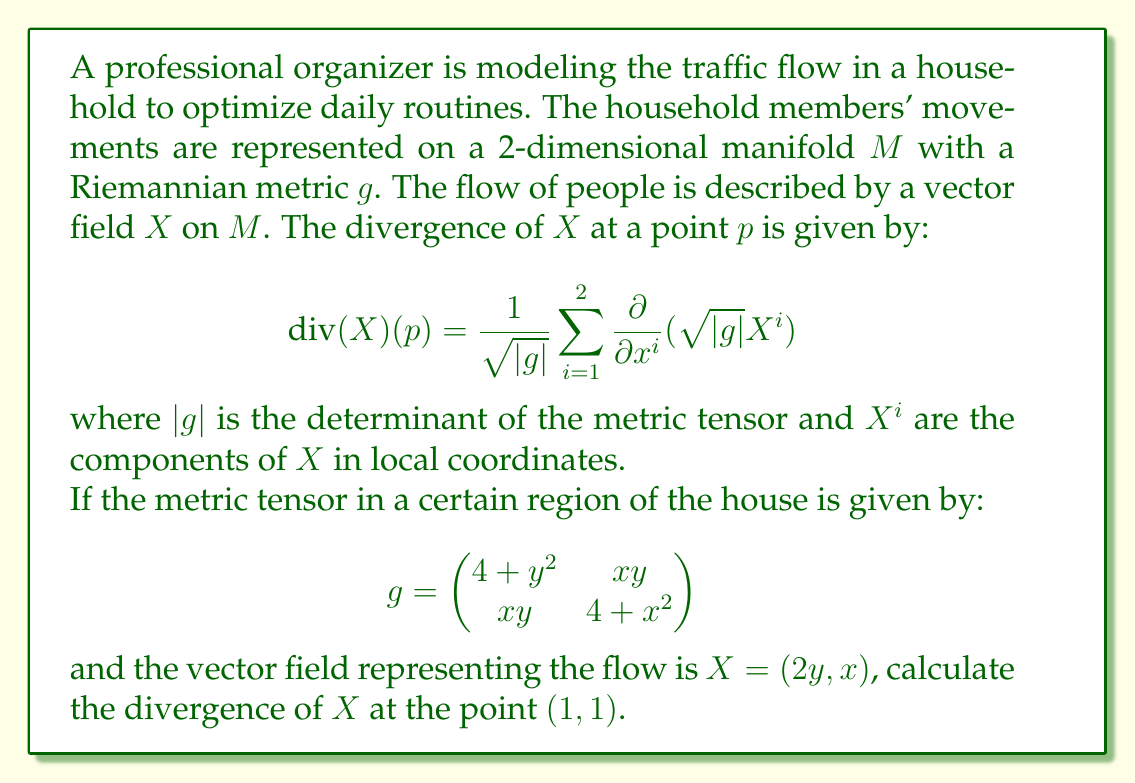Help me with this question. To solve this problem, we need to follow these steps:

1) First, we need to calculate $\sqrt{|g|}$:
   $|g| = (4+y^2)(4+x^2) - (xy)^2$
   At point (1,1): $|g| = (4+1)(4+1) - 1 = 24$
   So, $\sqrt{|g|} = 2\sqrt{6}$ at (1,1)

2) Now, we need to calculate $\frac{\partial}{\partial x^i}(\sqrt{|g|}X^i)$ for i = 1 and 2:

   For i = 1:
   $\frac{\partial}{\partial x}(\sqrt{|g|}X^1) = \frac{\partial}{\partial x}(\sqrt{|g|} \cdot 2y)$
   $= 2y \frac{\partial}{\partial x}(\sqrt{(4+y^2)(4+x^2) - (xy)^2})$
   
   For i = 2:
   $\frac{\partial}{\partial y}(\sqrt{|g|}X^2) = \frac{\partial}{\partial y}(\sqrt{|g|} \cdot x)$
   $= x \frac{\partial}{\partial y}(\sqrt{(4+y^2)(4+x^2) - (xy)^2}) + \sqrt{|g|}$

3) Evaluating these at (1,1):
   
   For i = 1:
   $\frac{\partial}{\partial x}(\sqrt{|g|}X^1)|_{(1,1)} = 2 \cdot \frac{1}{2\sqrt{6}} \cdot (5 \cdot 1 - 1) = \frac{4}{\sqrt{6}}$
   
   For i = 2:
   $\frac{\partial}{\partial y}(\sqrt{|g|}X^2)|_{(1,1)} = 1 \cdot \frac{1}{2\sqrt{6}} \cdot (5 \cdot 1 - 1) + 2\sqrt{6} = \frac{2}{\sqrt{6}} + 2\sqrt{6}$

4) Finally, we can calculate the divergence:

   $\text{div}(X)(1,1) = \frac{1}{\sqrt{|g|}}\sum_{i=1}^2 \frac{\partial}{\partial x^i}(\sqrt{|g|}X^i)$
   
   $= \frac{1}{2\sqrt{6}}(\frac{4}{\sqrt{6}} + \frac{2}{\sqrt{6}} + 2\sqrt{6})$
   
   $= \frac{1}{2\sqrt{6}}(\frac{6}{\sqrt{6}} + 2\sqrt{6})$
   
   $= \frac{1}{2\sqrt{6}}(\sqrt{6} + 2\sqrt{6})$
   
   $= \frac{3}{2}$
Answer: The divergence of $X$ at the point (1,1) is $\frac{3}{2}$. 